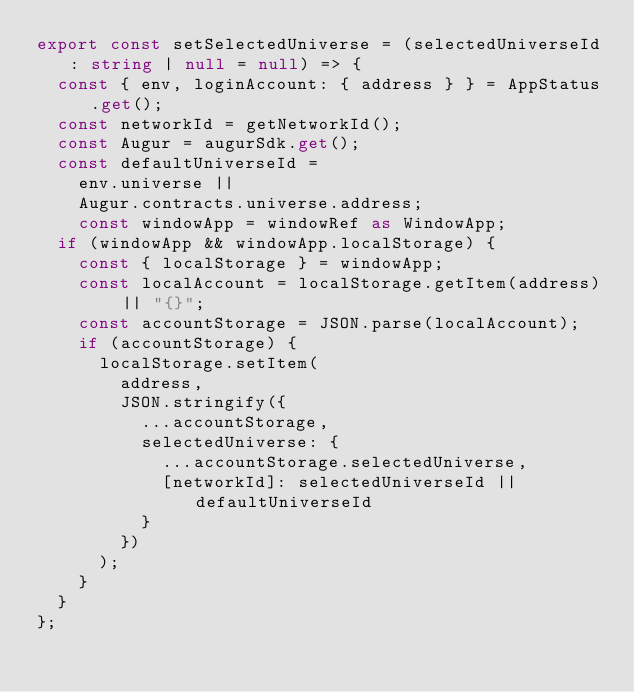<code> <loc_0><loc_0><loc_500><loc_500><_TypeScript_>export const setSelectedUniverse = (selectedUniverseId: string | null = null) => {
  const { env, loginAccount: { address } } = AppStatus.get();
  const networkId = getNetworkId();
  const Augur = augurSdk.get();
  const defaultUniverseId =
    env.universe ||
    Augur.contracts.universe.address;
    const windowApp = windowRef as WindowApp;
  if (windowApp && windowApp.localStorage) {
    const { localStorage } = windowApp;
    const localAccount = localStorage.getItem(address) || "{}";
    const accountStorage = JSON.parse(localAccount);
    if (accountStorage) {
      localStorage.setItem(
        address,
        JSON.stringify({
          ...accountStorage,
          selectedUniverse: {
            ...accountStorage.selectedUniverse,
            [networkId]: selectedUniverseId || defaultUniverseId
          }
        })
      );
    }
  }
};
</code> 